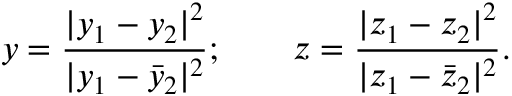Convert formula to latex. <formula><loc_0><loc_0><loc_500><loc_500>y = \frac { | y _ { 1 } - y _ { 2 } | ^ { 2 } } { | y _ { 1 } - { \bar { y } _ { 2 } } | ^ { 2 } } ; \quad z = \frac { | z _ { 1 } - z _ { 2 } | ^ { 2 } } { | z _ { 1 } - { \bar { z } _ { 2 } } | ^ { 2 } } .</formula> 